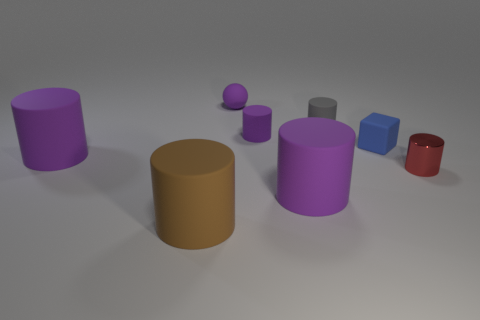What shape is the gray rubber object?
Offer a very short reply. Cylinder. How many objects are big matte cylinders that are left of the tiny metal thing or large purple shiny balls?
Offer a very short reply. 3. What is the size of the brown cylinder that is made of the same material as the tiny purple sphere?
Ensure brevity in your answer.  Large. Is the number of tiny objects that are behind the red thing greater than the number of small blue cubes?
Provide a short and direct response. Yes. Is the shape of the tiny gray matte thing the same as the large rubber object behind the tiny red object?
Provide a succinct answer. Yes. How many big things are brown matte things or gray objects?
Provide a short and direct response. 1. There is a big object to the right of the tiny purple object behind the small gray thing; what is its color?
Ensure brevity in your answer.  Purple. Is the blue object made of the same material as the tiny cylinder that is on the right side of the gray object?
Provide a short and direct response. No. What material is the large purple thing that is in front of the red thing?
Keep it short and to the point. Rubber. Are there an equal number of brown cylinders that are behind the brown rubber cylinder and green rubber balls?
Your response must be concise. Yes. 